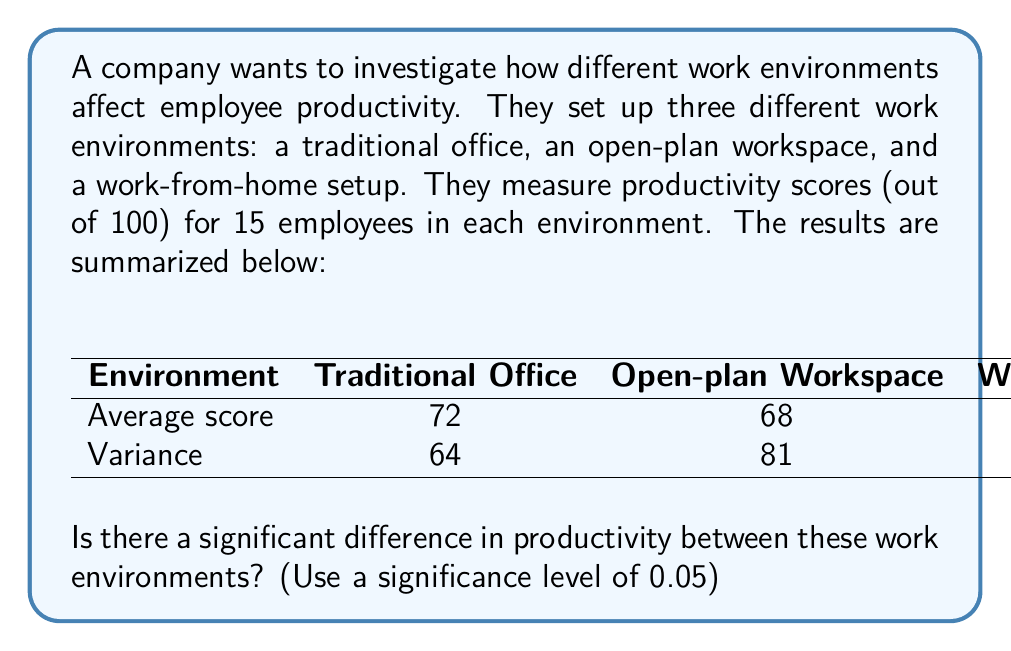What is the answer to this math problem? To determine if there's a significant difference in productivity between the work environments, we'll use a one-way ANOVA (Analysis of Variance) test. Here's how we'll approach this:

1. First, let's state our hypotheses:
   $H_0$: There is no significant difference in productivity between the work environments.
   $H_1$: There is a significant difference in productivity between at least two work environments.

2. We'll use the F-test in ANOVA. The F-statistic is calculated as:

   $$F = \frac{\text{Between-group variability}}{\text{Within-group variability}}$$

3. To calculate the F-statistic, we need:
   - The number of groups (k) = 3
   - The number of observations per group (n) = 15
   - The total number of observations (N) = 45

4. Calculate the between-group sum of squares (SSB):
   $$SSB = n \sum_{i=1}^k (\bar{X_i} - \bar{X})^2$$
   where $\bar{X}$ is the grand mean.

   $\bar{X} = \frac{72 + 68 + 75}{3} = 71.67$

   $$SSB = 15[(72 - 71.67)^2 + (68 - 71.67)^2 + (75 - 71.67)^2] = 367.5$$

5. Calculate the within-group sum of squares (SSW):
   $$SSW = (n-1)\sum_{i=1}^k s_i^2$$
   where $s_i^2$ is the variance of each group.

   $$SSW = 14(64 + 81 + 49) = 2716$$

6. Calculate the degrees of freedom:
   - Between groups: dfB = k - 1 = 2
   - Within groups: dfW = N - k = 42

7. Calculate the mean squares:
   $$MSB = \frac{SSB}{dfB} = \frac{367.5}{2} = 183.75$$
   $$MSW = \frac{SSW}{dfW} = \frac{2716}{42} = 64.67$$

8. Calculate the F-statistic:
   $$F = \frac{MSB}{MSW} = \frac{183.75}{64.67} = 2.84$$

9. Find the critical F-value:
   With α = 0.05, dfB = 2, and dfW = 42, the critical F-value is approximately 3.22.

10. Compare the F-statistic to the critical F-value:
    Since 2.84 < 3.22, we fail to reject the null hypothesis.
Answer: We fail to reject the null hypothesis. There is not enough evidence to conclude that there is a significant difference in productivity between the different work environments at the 0.05 significance level. 